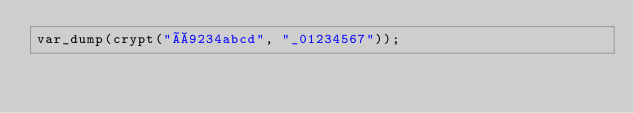<code> <loc_0><loc_0><loc_500><loc_500><_PHP_>var_dump(crypt("À9234abcd", "_01234567"));
</code> 